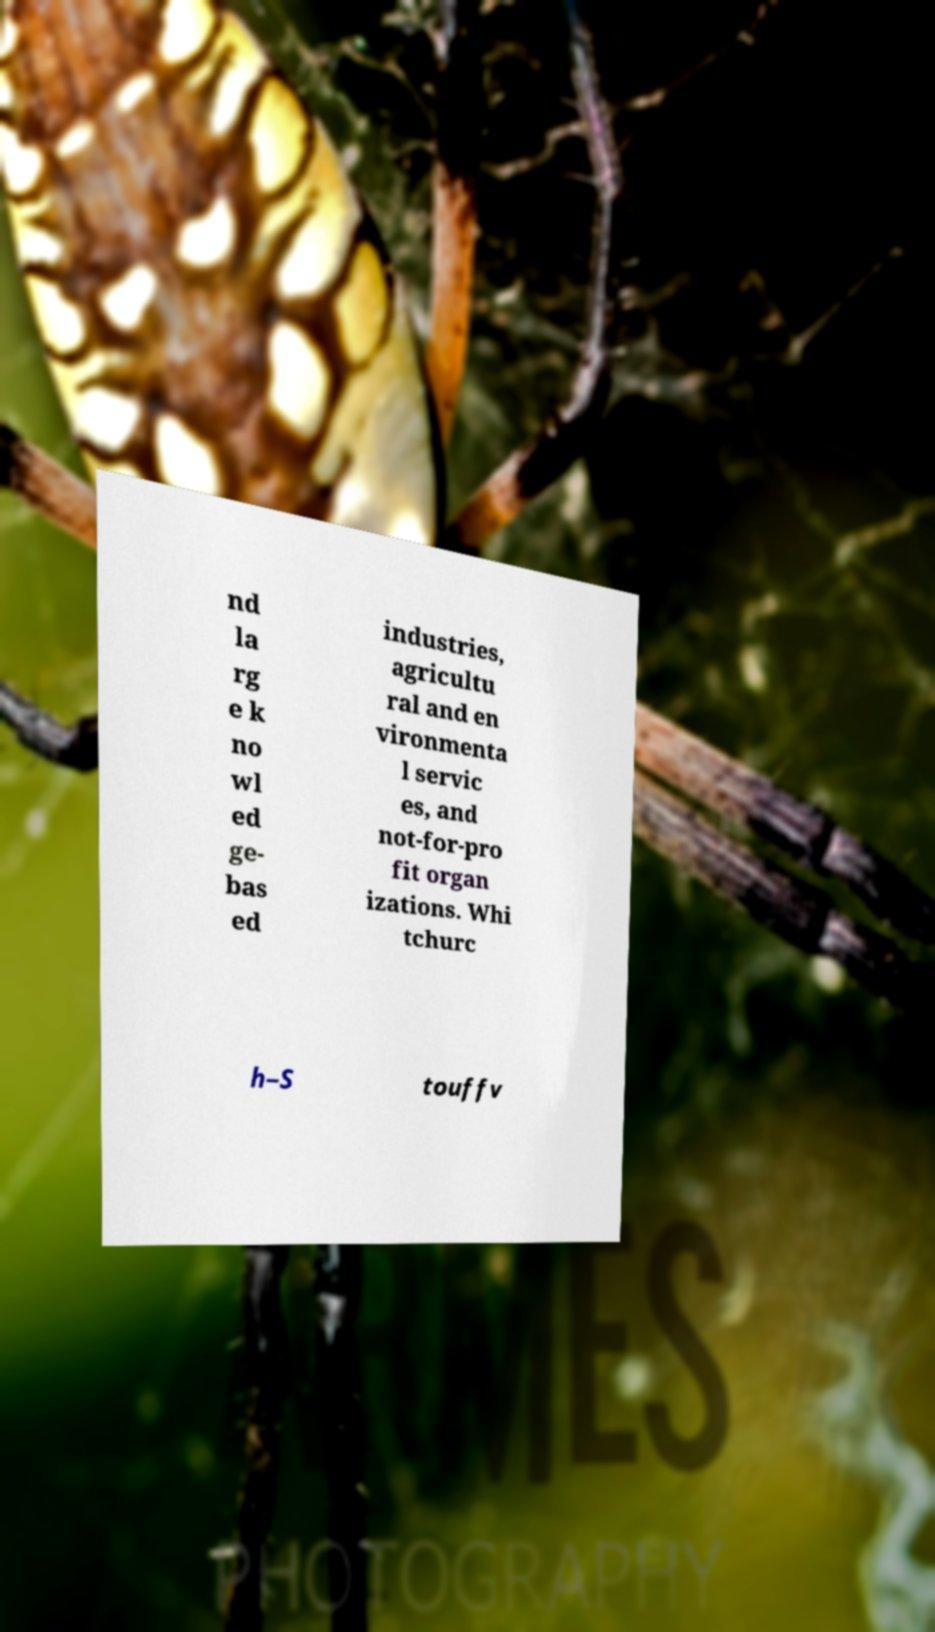Could you assist in decoding the text presented in this image and type it out clearly? nd la rg e k no wl ed ge- bas ed industries, agricultu ral and en vironmenta l servic es, and not-for-pro fit organ izations. Whi tchurc h–S touffv 